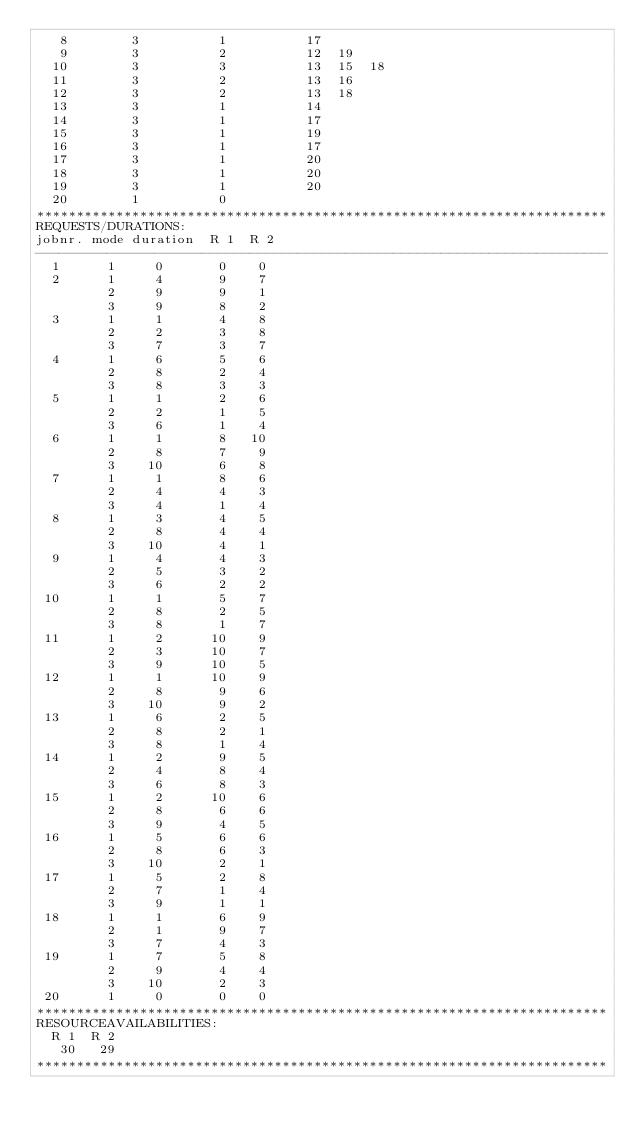<code> <loc_0><loc_0><loc_500><loc_500><_ObjectiveC_>   8        3          1          17
   9        3          2          12  19
  10        3          3          13  15  18
  11        3          2          13  16
  12        3          2          13  18
  13        3          1          14
  14        3          1          17
  15        3          1          19
  16        3          1          17
  17        3          1          20
  18        3          1          20
  19        3          1          20
  20        1          0        
************************************************************************
REQUESTS/DURATIONS:
jobnr. mode duration  R 1  R 2
------------------------------------------------------------------------
  1      1     0       0    0
  2      1     4       9    7
         2     9       9    1
         3     9       8    2
  3      1     1       4    8
         2     2       3    8
         3     7       3    7
  4      1     6       5    6
         2     8       2    4
         3     8       3    3
  5      1     1       2    6
         2     2       1    5
         3     6       1    4
  6      1     1       8   10
         2     8       7    9
         3    10       6    8
  7      1     1       8    6
         2     4       4    3
         3     4       1    4
  8      1     3       4    5
         2     8       4    4
         3    10       4    1
  9      1     4       4    3
         2     5       3    2
         3     6       2    2
 10      1     1       5    7
         2     8       2    5
         3     8       1    7
 11      1     2      10    9
         2     3      10    7
         3     9      10    5
 12      1     1      10    9
         2     8       9    6
         3    10       9    2
 13      1     6       2    5
         2     8       2    1
         3     8       1    4
 14      1     2       9    5
         2     4       8    4
         3     6       8    3
 15      1     2      10    6
         2     8       6    6
         3     9       4    5
 16      1     5       6    6
         2     8       6    3
         3    10       2    1
 17      1     5       2    8
         2     7       1    4
         3     9       1    1
 18      1     1       6    9
         2     1       9    7
         3     7       4    3
 19      1     7       5    8
         2     9       4    4
         3    10       2    3
 20      1     0       0    0
************************************************************************
RESOURCEAVAILABILITIES:
  R 1  R 2
   30   29
************************************************************************
</code> 